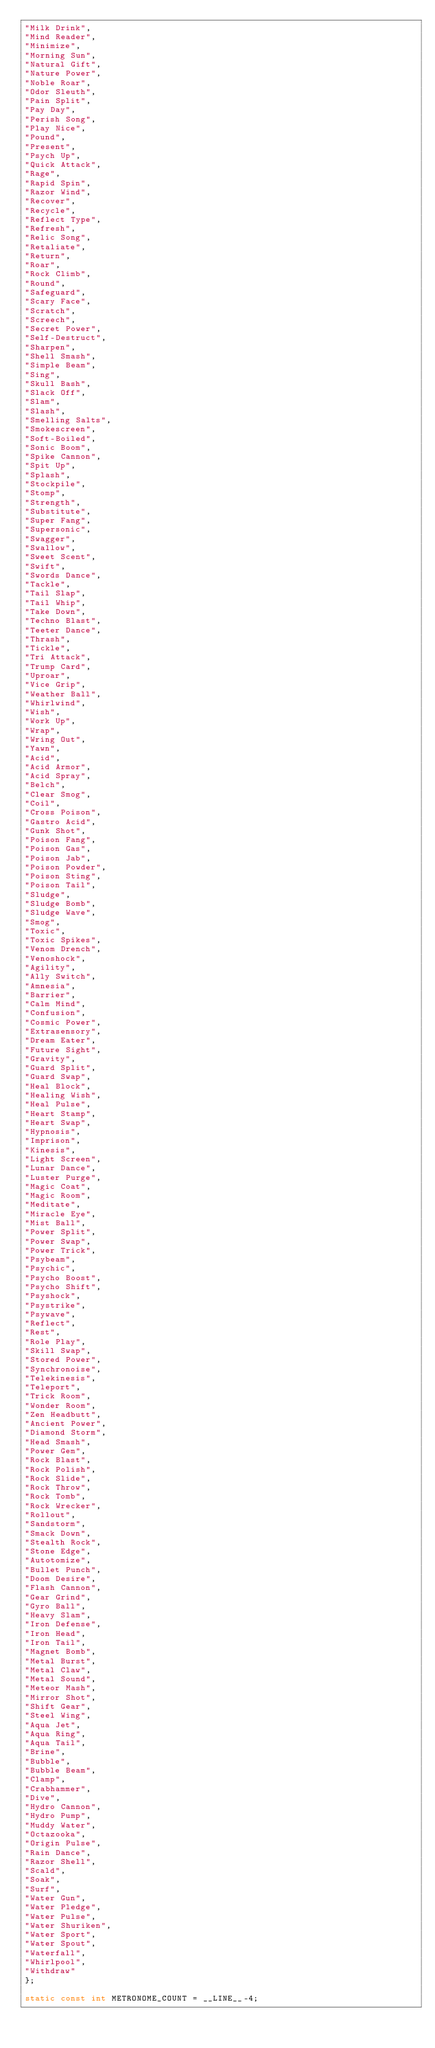<code> <loc_0><loc_0><loc_500><loc_500><_C_>"Milk Drink",
"Mind Reader",
"Minimize",
"Morning Sun",
"Natural Gift",
"Nature Power",
"Noble Roar",
"Odor Sleuth",
"Pain Split",
"Pay Day",
"Perish Song",
"Play Nice",
"Pound",
"Present",
"Psych Up",
"Quick Attack",
"Rage",
"Rapid Spin",
"Razor Wind",
"Recover",
"Recycle",
"Reflect Type",
"Refresh",
"Relic Song",
"Retaliate",
"Return",
"Roar",
"Rock Climb",
"Round",
"Safeguard",
"Scary Face",
"Scratch",
"Screech",
"Secret Power",
"Self-Destruct",
"Sharpen",
"Shell Smash",
"Simple Beam",
"Sing",
"Skull Bash",
"Slack Off",
"Slam",
"Slash",
"Smelling Salts",
"Smokescreen",
"Soft-Boiled",
"Sonic Boom",
"Spike Cannon",
"Spit Up",
"Splash",
"Stockpile",
"Stomp",
"Strength",
"Substitute",
"Super Fang",
"Supersonic",
"Swagger",
"Swallow",
"Sweet Scent",
"Swift",
"Swords Dance",
"Tackle",
"Tail Slap",
"Tail Whip",
"Take Down",
"Techno Blast",
"Teeter Dance",
"Thrash",
"Tickle",
"Tri Attack",
"Trump Card",
"Uproar",
"Vice Grip",
"Weather Ball",
"Whirlwind",
"Wish",
"Work Up",
"Wrap",
"Wring Out",
"Yawn",
"Acid",
"Acid Armor",
"Acid Spray",
"Belch",
"Clear Smog",
"Coil",
"Cross Poison",
"Gastro Acid",
"Gunk Shot",
"Poison Fang",
"Poison Gas",
"Poison Jab",
"Poison Powder",
"Poison Sting",
"Poison Tail",
"Sludge",
"Sludge Bomb",
"Sludge Wave",
"Smog",
"Toxic",
"Toxic Spikes",
"Venom Drench",
"Venoshock",
"Agility",
"Ally Switch",
"Amnesia",
"Barrier",
"Calm Mind",
"Confusion",
"Cosmic Power",
"Extrasensory",
"Dream Eater",
"Future Sight",
"Gravity",
"Guard Split",
"Guard Swap",
"Heal Block",
"Healing Wish",
"Heal Pulse",
"Heart Stamp",
"Heart Swap",
"Hypnosis",
"Imprison",
"Kinesis",
"Light Screen",
"Lunar Dance",
"Luster Purge",
"Magic Coat",
"Magic Room",
"Meditate",
"Miracle Eye",
"Mist Ball",
"Power Split",
"Power Swap",
"Power Trick",
"Psybeam",
"Psychic",
"Psycho Boost",
"Psycho Shift",
"Psyshock",
"Psystrike",
"Psywave",
"Reflect",
"Rest",
"Role Play",
"Skill Swap",
"Stored Power",
"Synchronoise",
"Telekinesis",
"Teleport",
"Trick Room",
"Wonder Room",
"Zen Headbutt",
"Ancient Power",
"Diamond Storm",
"Head Smash",
"Power Gem",
"Rock Blast",
"Rock Polish",
"Rock Slide",
"Rock Throw",
"Rock Tomb",
"Rock Wrecker",
"Rollout",
"Sandstorm",
"Smack Down",
"Stealth Rock",
"Stone Edge",
"Autotomize",
"Bullet Punch",
"Doom Desire",
"Flash Cannon",
"Gear Grind",
"Gyro Ball",
"Heavy Slam",
"Iron Defense",
"Iron Head",
"Iron Tail",
"Magnet Bomb",
"Metal Burst",
"Metal Claw",
"Metal Sound",
"Meteor Mash",
"Mirror Shot",
"Shift Gear",
"Steel Wing",
"Aqua Jet",
"Aqua Ring",
"Aqua Tail",
"Brine",
"Bubble",
"Bubble Beam",
"Clamp",
"Crabhammer",
"Dive",
"Hydro Cannon",
"Hydro Pump",
"Muddy Water",
"Octazooka",
"Origin Pulse",
"Rain Dance",
"Razor Shell",
"Scald",
"Soak",
"Surf",
"Water Gun",
"Water Pledge",
"Water Pulse",
"Water Shuriken",
"Water Sport",
"Water Spout",
"Waterfall",
"Whirlpool",
"Withdraw"
};

static const int METRONOME_COUNT = __LINE__-4;</code> 